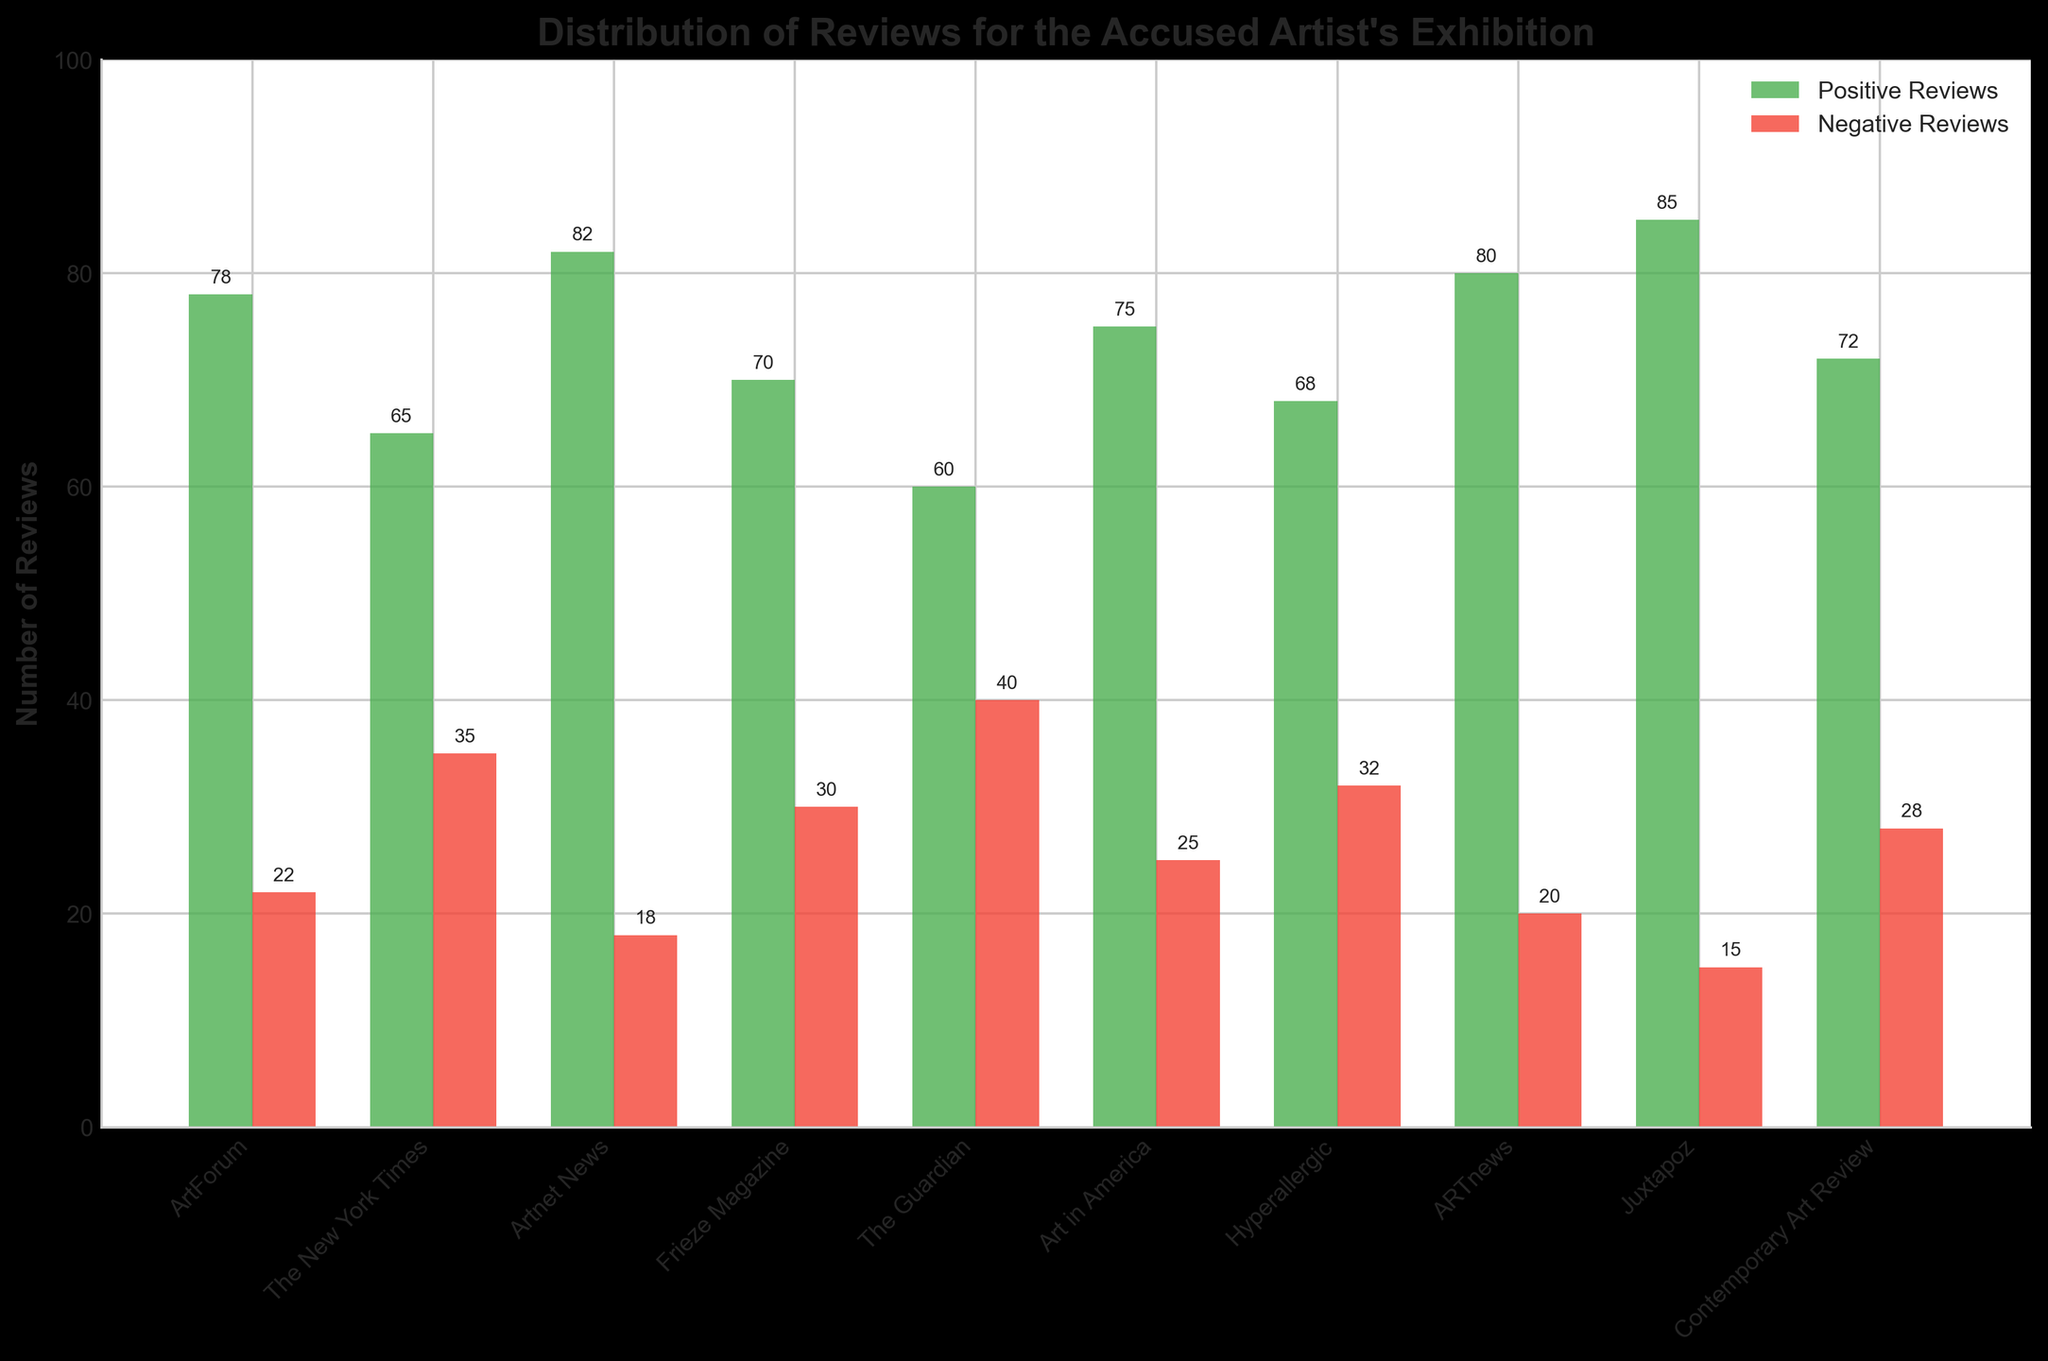What is the total number of positive reviews from Artnet News and Juxtapoz? From the figure, Artnet News has 82 positive reviews, and Juxtapoz has 85 positive reviews. Summing these values gives 82 + 85 = 167.
Answer: 167 Which art critique source has the highest number of negative reviews? By visually comparing the heights of the red bars representing negative reviews, The Guardian has the highest number, which is 40.
Answer: The Guardian What is the difference between positive and negative reviews for the Frieze Magazine? The figure shows Frieze Magazine has 70 positive reviews and 30 negative reviews. The difference is 70 - 30 = 40.
Answer: 40 How many more positive reviews did ARTnews receive compared to Art in America? ARTnews received 80 positive reviews, while Art in America received 75. The difference is 80 - 75 = 5.
Answer: 5 Find the sum of negative reviews from ArtForum, The New York Times, and Hyperallergic. ArtForum has 22 negative reviews, The New York Times has 35, and Hyperallergic has 32. Summing these values gives 22 + 35 + 32 = 89.
Answer: 89 What is the average number of positive reviews from all the sources? Sum all the positive reviews: 78 + 65 + 82 + 70 + 60 + 75 + 68 + 80 + 85 + 72 = 735. There are 10 sources, so the average is 735 / 10 = 73.5.
Answer: 73.5 Which source has the smallest difference between positive and negative reviews? By comparing the difference visually for each source: 
- ArtForum: 78 - 22 = 56 
- The New York Times: 65 - 35 = 30 
- Artnet News: 82 - 18 = 64 
- Frieze Magazine: 70 - 30 = 40 
- The Guardian: 60 - 40 = 20 
- Art in America: 75 - 25 = 50 
- Hyperallergic: 68 - 32 = 36 
- ARTnews: 80 - 20 = 60 
- Juxtapoz: 85 - 15 = 70 
- Contemporary Art Review: 72 - 28 = 44 
The Guardian has the smallest difference of 20.
Answer: The Guardian Which source has more positive reviews, Hyperallergic or Contemporary Art Review? From the figure, Hyperallergic has 68 positive reviews, while Contemporary Art Review has 72 positive reviews.
Answer: Contemporary Art Review What is the combined number of reviews (both positive and negative) for Frieze Magazine? Frieze Magazine has 70 positive reviews and 30 negative reviews. The combined number is 70 + 30 = 100.
Answer: 100 Between ArtForum and ARTnews, which one has a higher ratio of positive to negative reviews? - ArtForum: Positive = 78, Negative = 22, Ratio = 78 / 22 ≈ 3.55
- ARTnews: Positive = 80, Negative = 20, Ratio = 80 / 20 = 4
Comparing these ratios, ARTnews has a higher ratio.
Answer: ARTnews 